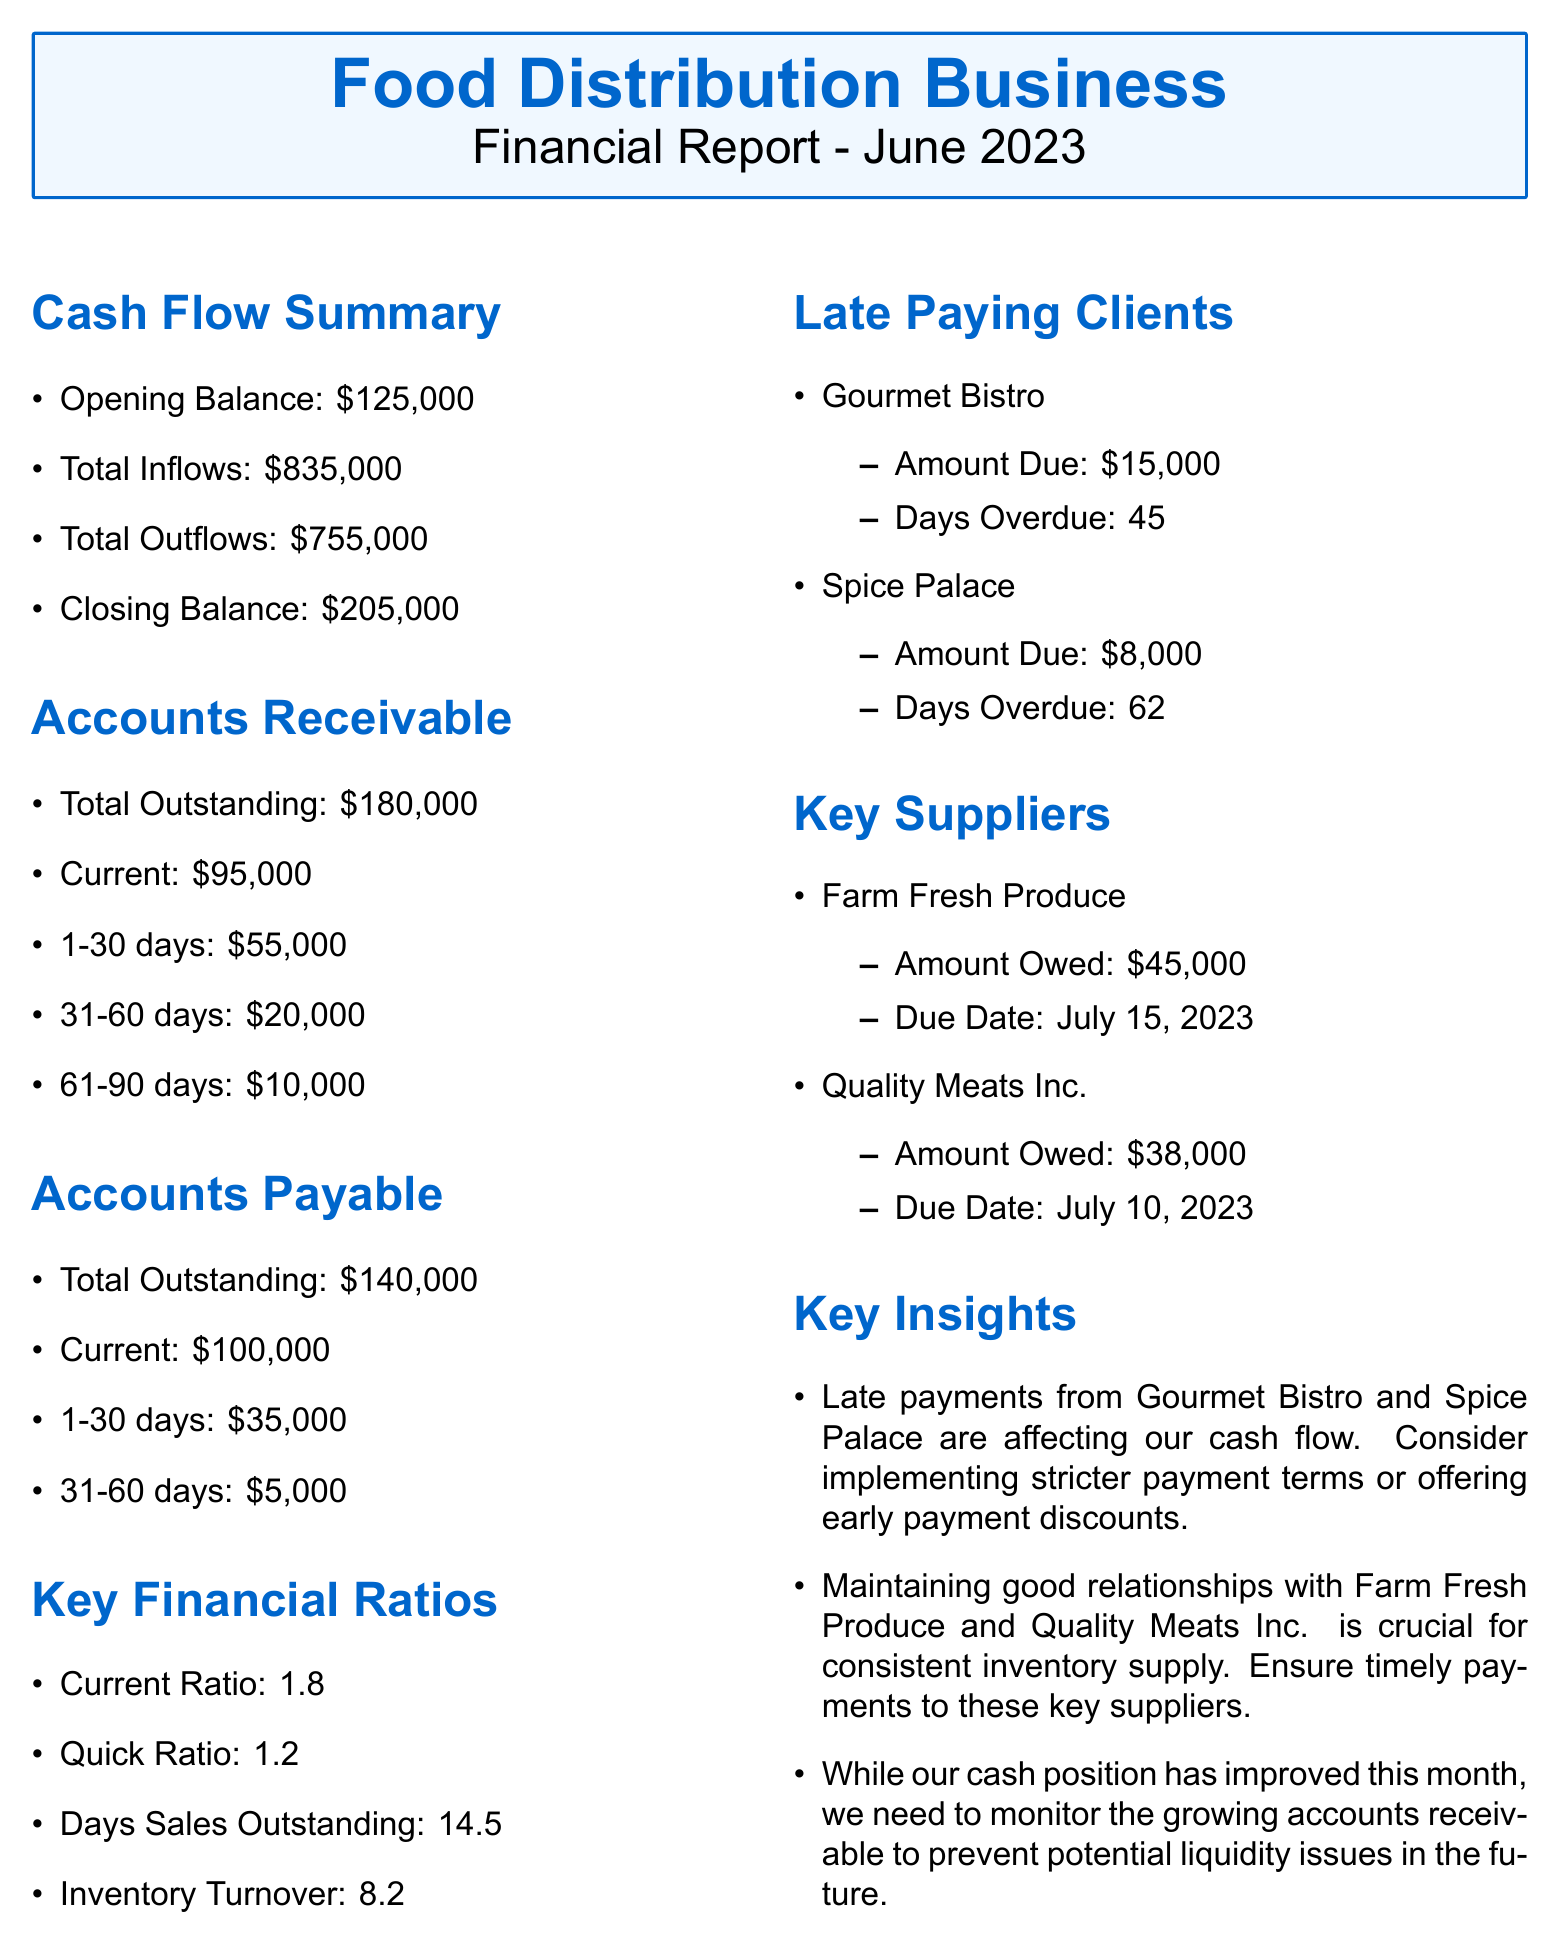What is the total cash inflow for June 2023? The total cash inflow is the sum of sales revenue, accounts receivable collected, and other income, which is \$450,000 + \$380,000 + \$5,000 = \$835,000.
Answer: \$835,000 What is the amount due from Spice Palace? The document states that the amount due from Spice Palace is specified as \$8,000.
Answer: \$8,000 How many days overdue is Gourmet Bistro payment? The document indicates that Gourmet Bistro's payment is overdue by 45 days, stated in the late paying clients section.
Answer: 45 days What is the total outstanding amount for accounts payable? The total outstanding amount for accounts payable is given as \$140,000 in the document.
Answer: \$140,000 What is the payment due date for Quality Meats Inc.? The payment due date for Quality Meats Inc. is mentioned as July 10, 2023, in the key suppliers section.
Answer: July 10, 2023 What impact do late payments have according to the insights? The insights suggest that late payments are affecting cash flow, implying the need for stricter payment terms or discounts.
Answer: Affecting cash flow What is the current ratio reported in the financial ratios? The current ratio is specified as 1.8 in the key financial ratios section.
Answer: 1.8 What is the total amount collected from accounts receivable? The total amount collected from accounts receivable is mentioned as \$380,000 in the cash inflow section.
Answer: \$380,000 What should be ensured regarding key suppliers? The insights section states that timely payments to key suppliers should be ensured to maintain good relationships.
Answer: Timely payments 